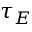<formula> <loc_0><loc_0><loc_500><loc_500>\tau _ { E }</formula> 